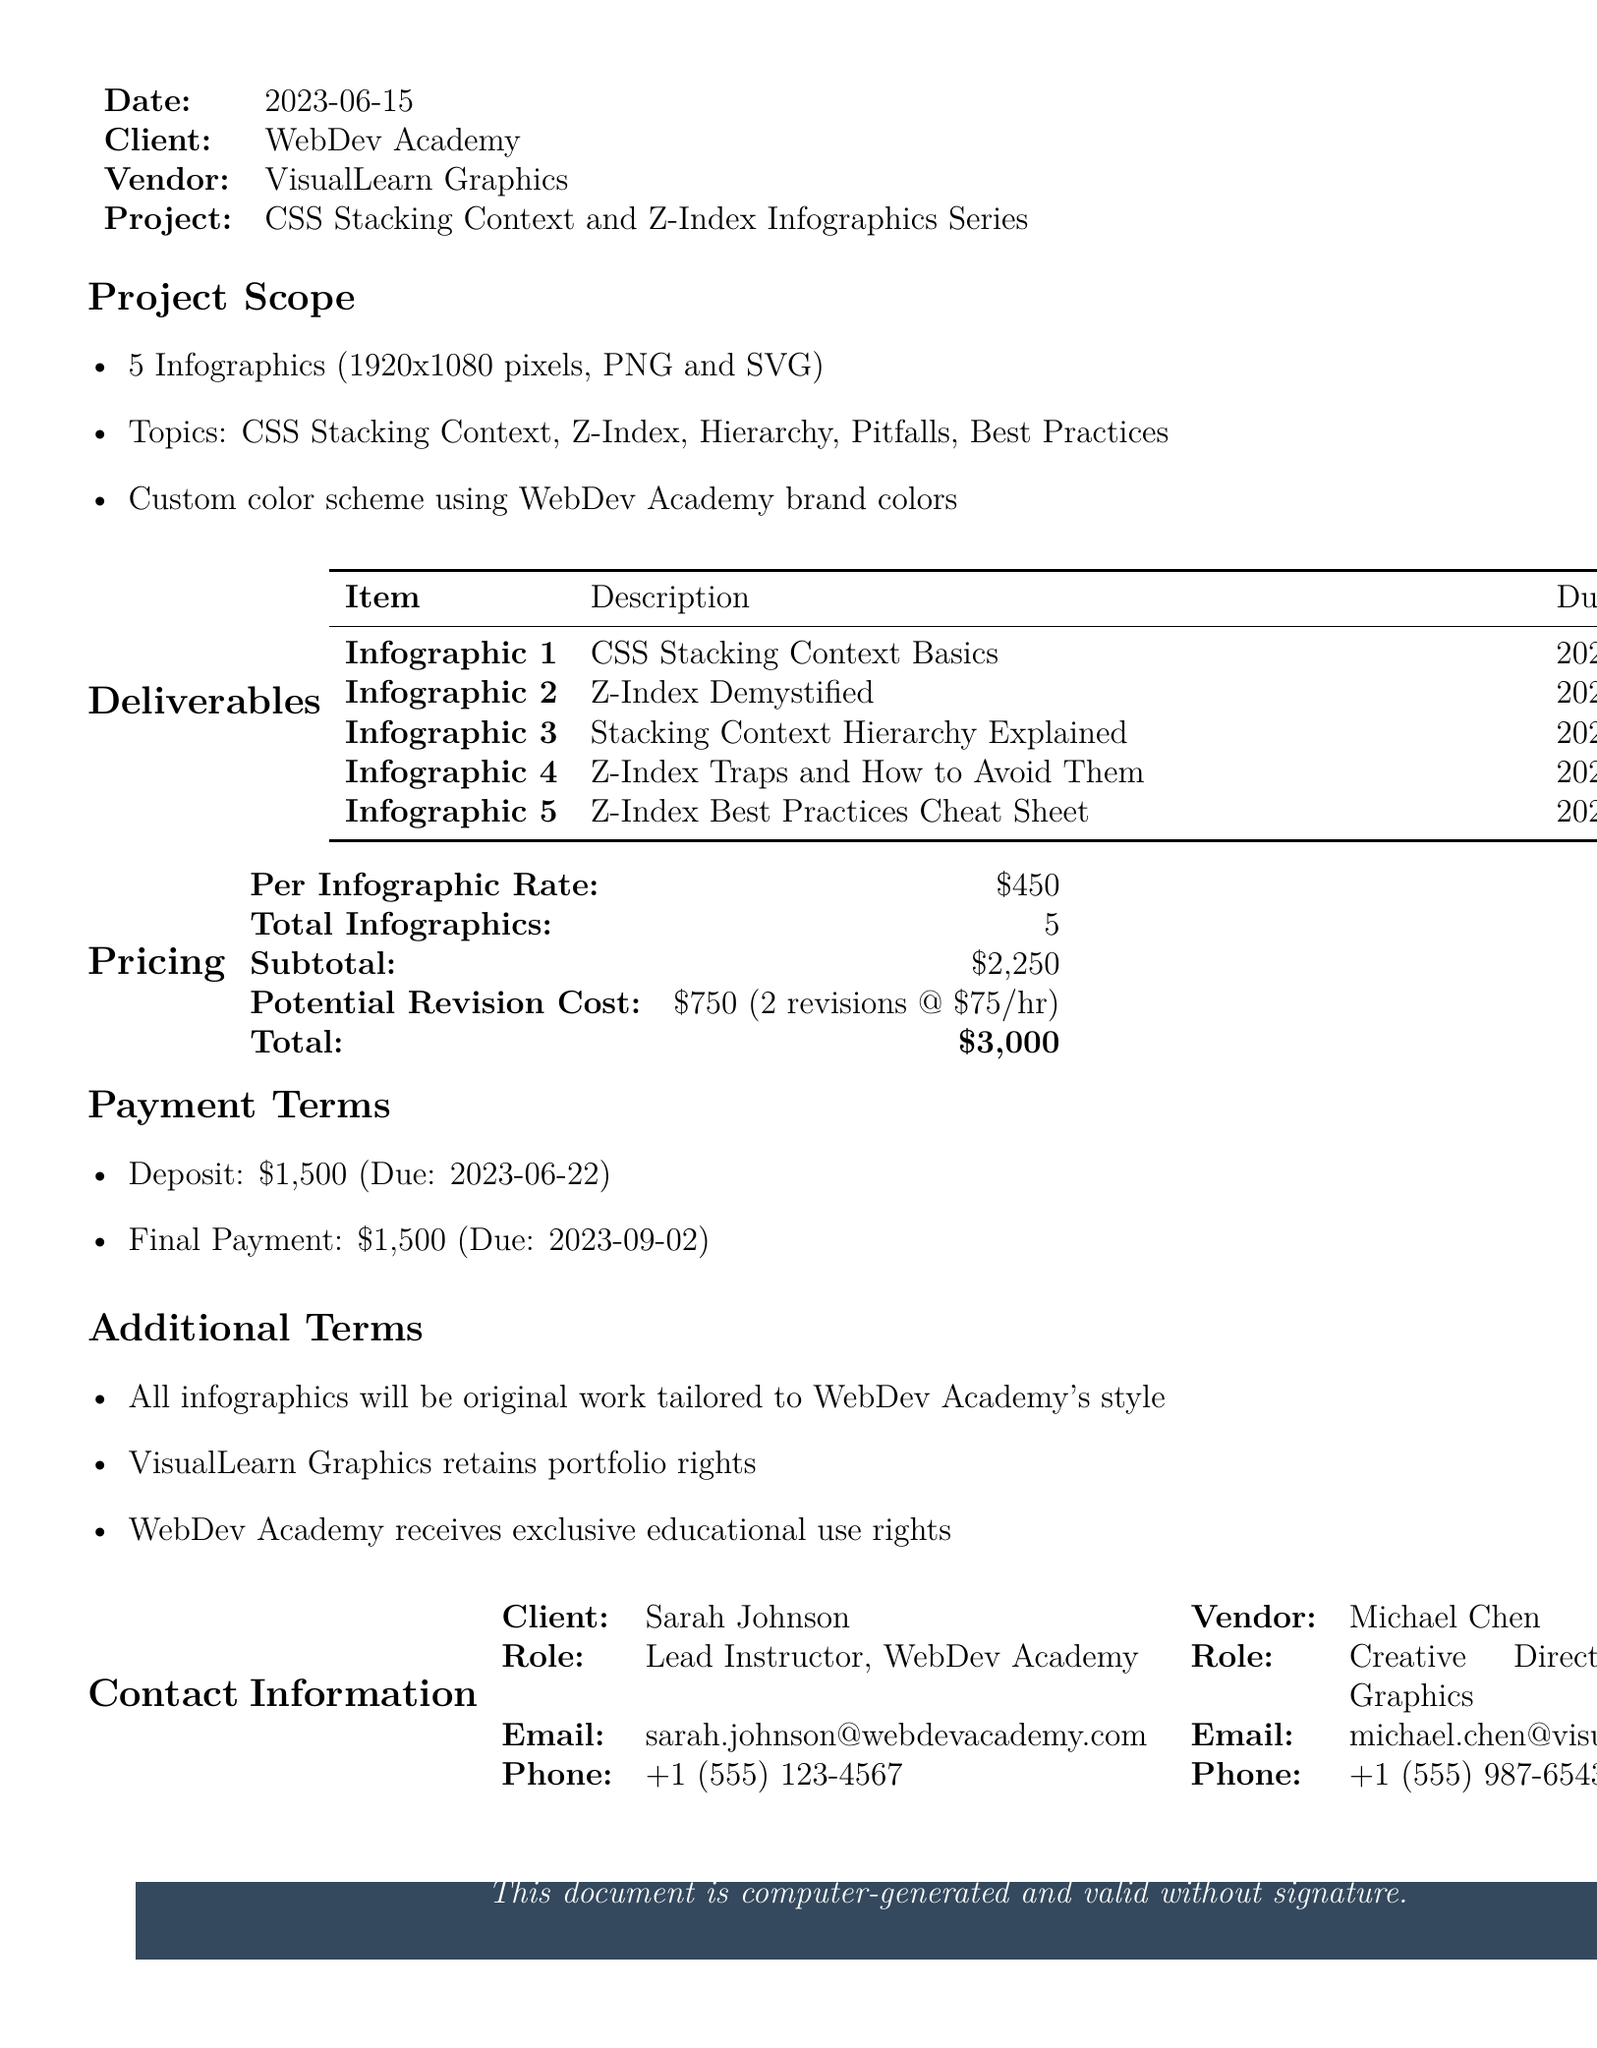What is the transaction ID? The transaction ID is mentioned at the top of the document, which is a unique identifier for this transaction.
Answer: TRX-20230615-CSS-001 What is the due date for the final payment? The final payment due date is specified in the payment terms section of the document.
Answer: 2023-09-02 Who is the client? The document states the name of the entity that commissioned the infographics.
Answer: WebDev Academy How many infographics are to be delivered? The total number of infographics is listed in the project scope section.
Answer: 5 What is the subtotal for the infographics? The subtotal amount before any additional costs or revisions is provided in the pricing section.
Answer: $2250 What is the role of the client contact person? This information is found in the contact information section of the document.
Answer: Lead Instructor What is the color scheme for the infographics? The color scheme used for the infographics is described under the project scope section.
Answer: WebDev Academy brand colors What is the total potential revision cost? The potential revision cost is calculated based on the number of revisions allowed and the rate per revision mentioned in pricing.
Answer: $750 What topic does Infographic 3 cover? The specific topic of each infographic is listed in the deliverables section.
Answer: Stacking Context Hierarchy Explained 